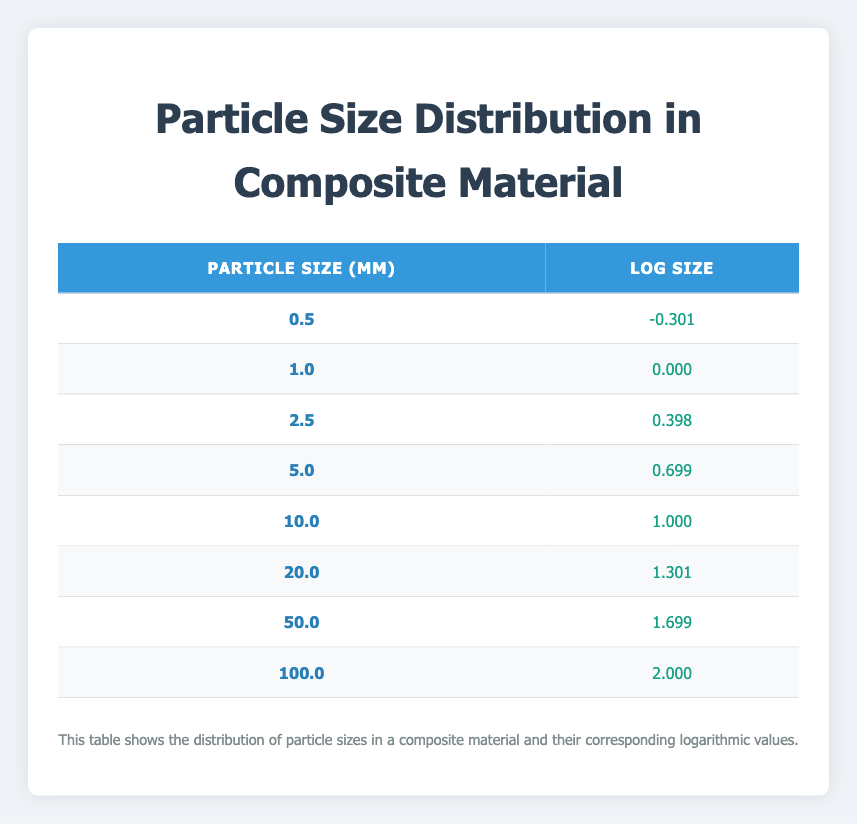What is the particle size of 10.0 micrometers? The table directly shows that for a particle size of 10.0 micrometers, the corresponding log size value is 1.000.
Answer: 1.000 What is the log size for the particle size of 5.0 micrometers? By checking the table, we find that the log size corresponding to a particle size of 5.0 micrometers is 0.699.
Answer: 0.699 Is the log size of 50.0 micrometers greater than 1.0? Looking at the table, the log size for 50.0 micrometers is 1.699, which is indeed greater than 1.0.
Answer: Yes What is the average log size of the particles listed in the table? To find the average log size, we add all the log size values: (-0.301 + 0.000 + 0.398 + 0.699 + 1.000 + 1.301 + 1.699 + 2.000) = 7.796. Dividing this by the number of data points (8), we get 7.796 / 8 = 0.9745, which can be rounded to 0.975.
Answer: 0.975 How many particle sizes have a log size greater than 1.0? From the table, we can see that the log sizes greater than 1.0 are: 1.000 (10.0 μm), 1.301 (20.0 μm), 1.699 (50.0 μm), and 2.000 (100.0 μm). So, there are four particle sizes with log sizes greater than 1.0.
Answer: 4 What is the difference in log size between the smallest (0.5 μm) and largest (100.0 μm) particles? The log size for the smallest particle (0.5 μm) is -0.301, and for the largest particle (100 μm) it is 2.000. The difference is calculated as 2.000 - (-0.301) = 2.000 + 0.301 = 2.301.
Answer: 2.301 Do any of the log sizes equal zero? Reviewing the table, we see that the log size of 1.0 micrometer is 0.000, confirming that there is indeed a log size that equals zero.
Answer: Yes Which particle size has the highest log size value? The table indicates that the largest log size value is 2.000, which corresponds to the particle size of 100.0 micrometers.
Answer: 100.0 μm 